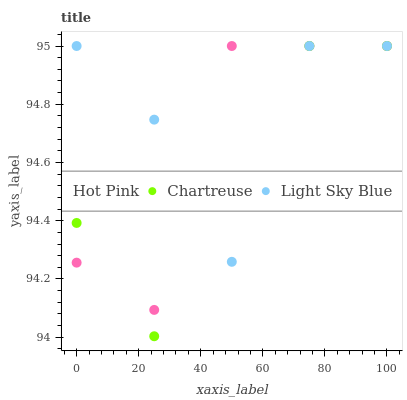Does Chartreuse have the minimum area under the curve?
Answer yes or no. Yes. Does Light Sky Blue have the maximum area under the curve?
Answer yes or no. Yes. Does Hot Pink have the minimum area under the curve?
Answer yes or no. No. Does Hot Pink have the maximum area under the curve?
Answer yes or no. No. Is Chartreuse the smoothest?
Answer yes or no. Yes. Is Light Sky Blue the roughest?
Answer yes or no. Yes. Is Hot Pink the smoothest?
Answer yes or no. No. Is Hot Pink the roughest?
Answer yes or no. No. Does Chartreuse have the lowest value?
Answer yes or no. Yes. Does Hot Pink have the lowest value?
Answer yes or no. No. Does Light Sky Blue have the highest value?
Answer yes or no. Yes. Does Hot Pink intersect Light Sky Blue?
Answer yes or no. Yes. Is Hot Pink less than Light Sky Blue?
Answer yes or no. No. Is Hot Pink greater than Light Sky Blue?
Answer yes or no. No. 